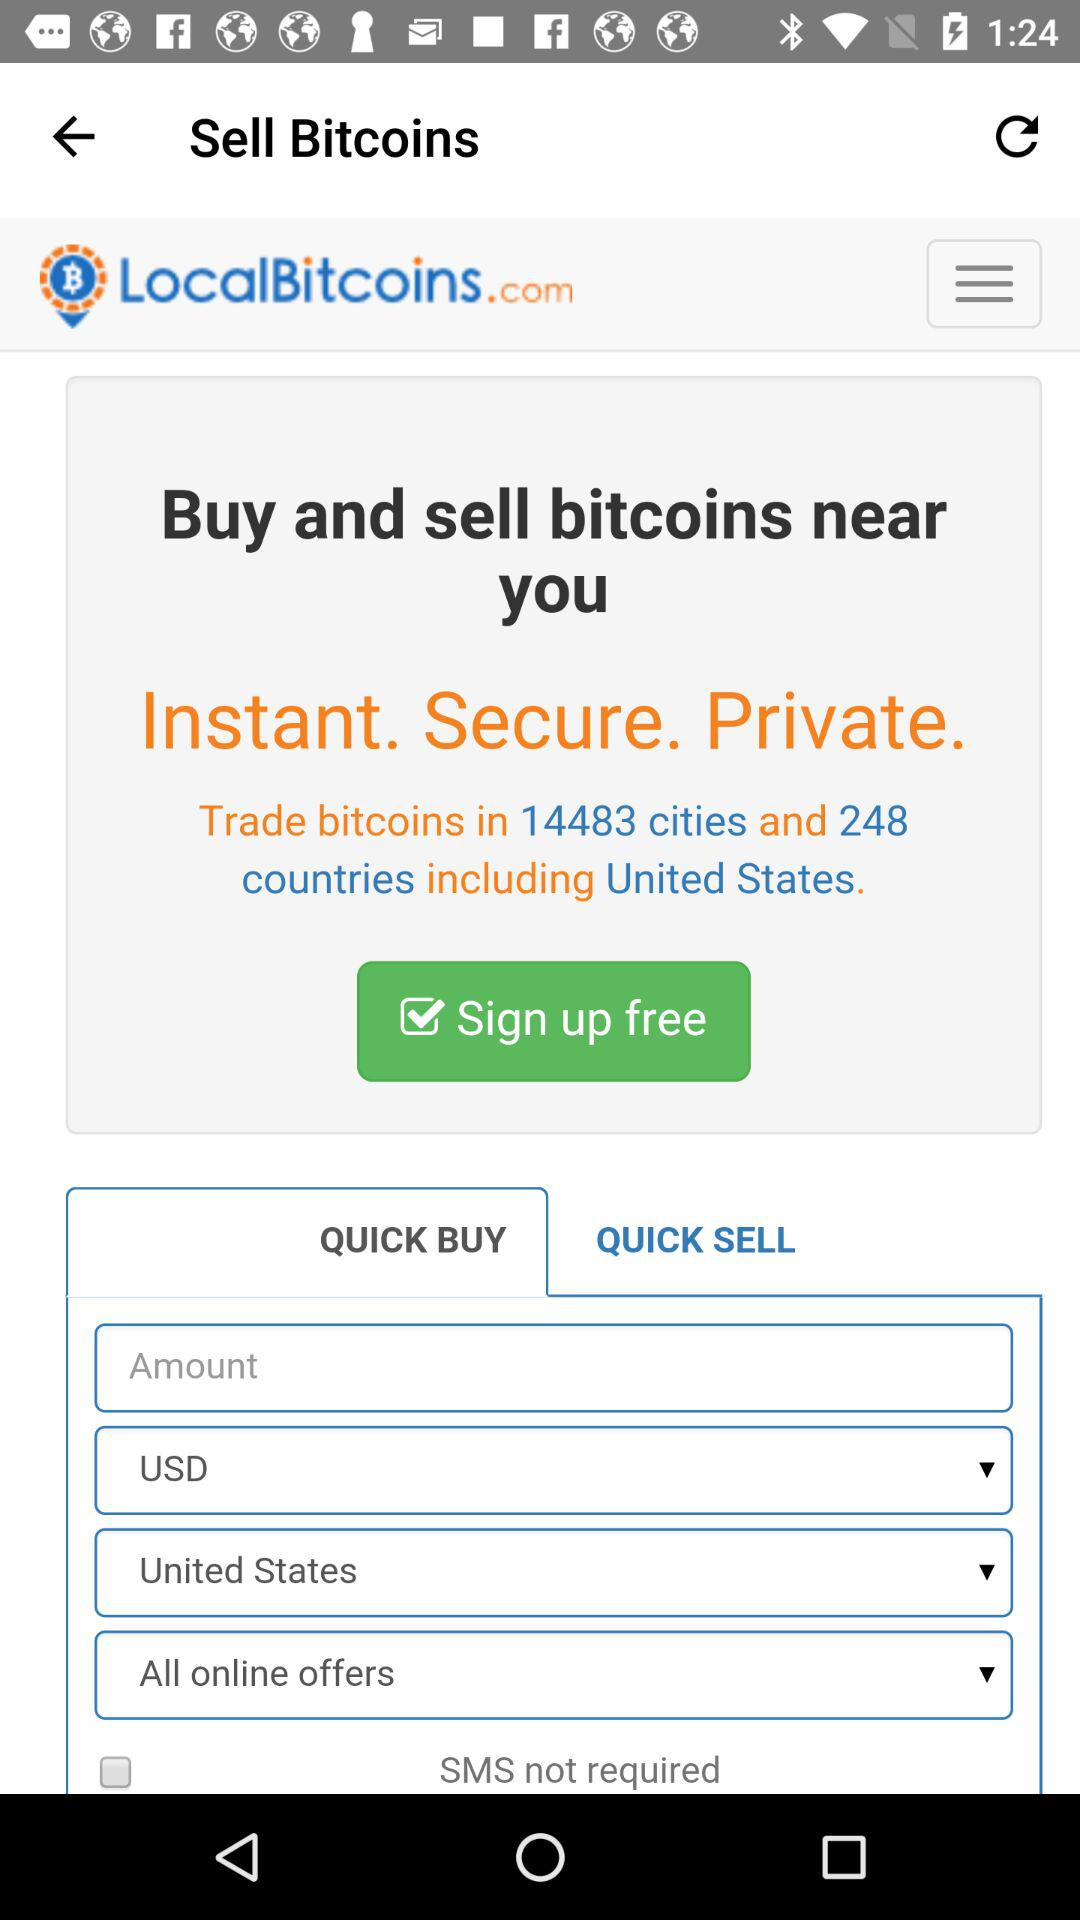In how many countries are bitcoins traded? Bitcoins are traded in 248 countries. 